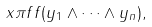Convert formula to latex. <formula><loc_0><loc_0><loc_500><loc_500>x \pi f f ( y _ { 1 } \land \cdots \land y _ { n } ) ,</formula> 